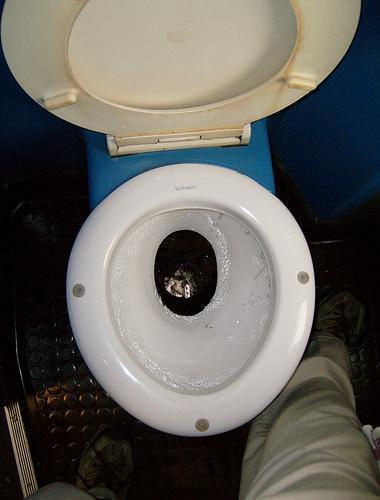How many toilets is in the picture?
Give a very brief answer. 1. 